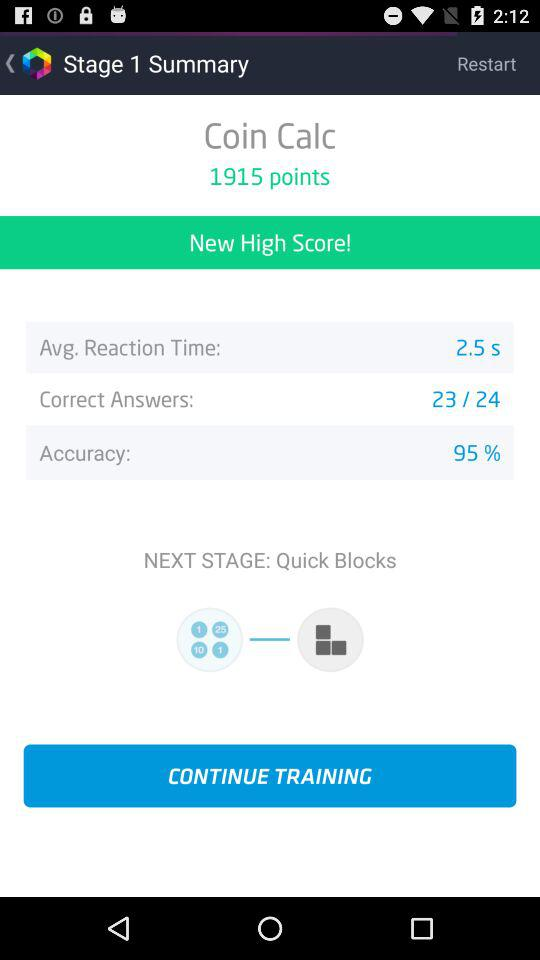What is the "Accuracy" of answers? The "Accuracy" is 95%. 